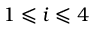Convert formula to latex. <formula><loc_0><loc_0><loc_500><loc_500>1 \leqslant i \leqslant 4</formula> 